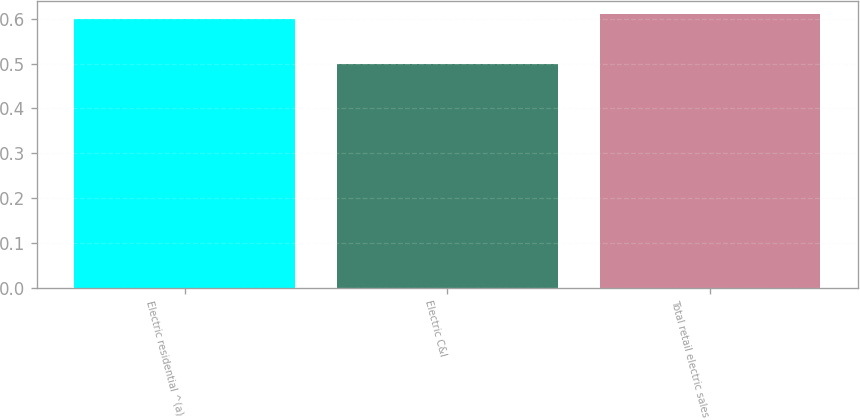Convert chart to OTSL. <chart><loc_0><loc_0><loc_500><loc_500><bar_chart><fcel>Electric residential ^(a)<fcel>Electric C&I<fcel>Total retail electric sales<nl><fcel>0.6<fcel>0.5<fcel>0.61<nl></chart> 